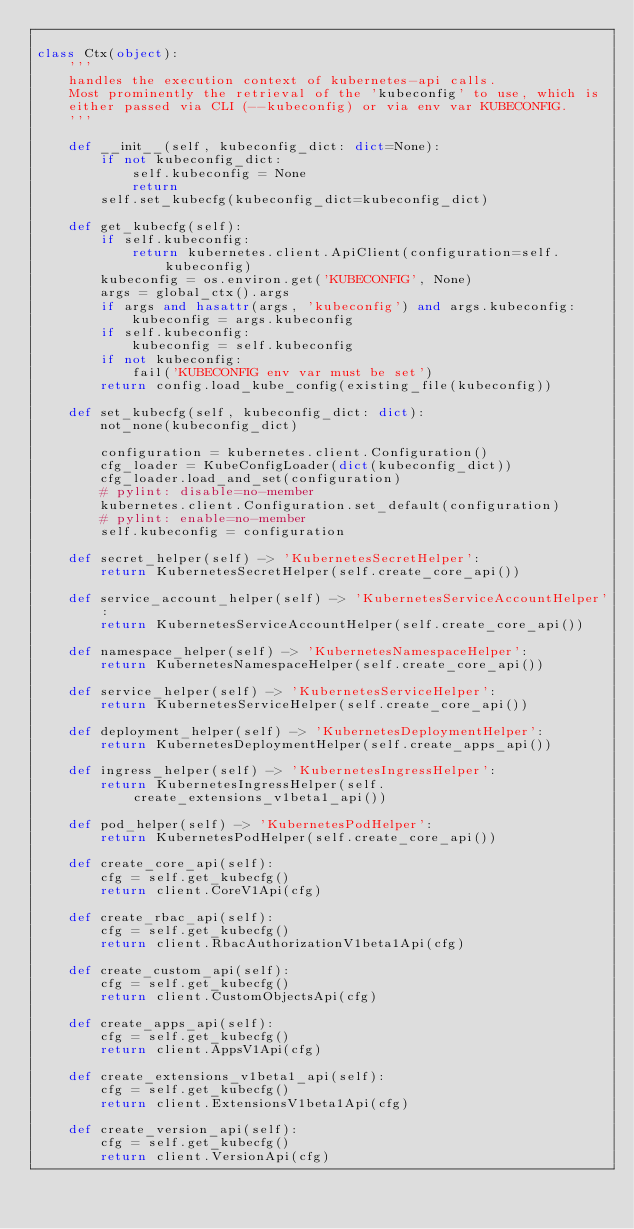Convert code to text. <code><loc_0><loc_0><loc_500><loc_500><_Python_>
class Ctx(object):
    '''
    handles the execution context of kubernetes-api calls.
    Most prominently the retrieval of the 'kubeconfig' to use, which is
    either passed via CLI (--kubeconfig) or via env var KUBECONFIG.
    '''

    def __init__(self, kubeconfig_dict: dict=None):
        if not kubeconfig_dict:
            self.kubeconfig = None
            return
        self.set_kubecfg(kubeconfig_dict=kubeconfig_dict)

    def get_kubecfg(self):
        if self.kubeconfig:
            return kubernetes.client.ApiClient(configuration=self.kubeconfig)
        kubeconfig = os.environ.get('KUBECONFIG', None)
        args = global_ctx().args
        if args and hasattr(args, 'kubeconfig') and args.kubeconfig:
            kubeconfig = args.kubeconfig
        if self.kubeconfig:
            kubeconfig = self.kubeconfig
        if not kubeconfig:
            fail('KUBECONFIG env var must be set')
        return config.load_kube_config(existing_file(kubeconfig))

    def set_kubecfg(self, kubeconfig_dict: dict):
        not_none(kubeconfig_dict)

        configuration = kubernetes.client.Configuration()
        cfg_loader = KubeConfigLoader(dict(kubeconfig_dict))
        cfg_loader.load_and_set(configuration)
        # pylint: disable=no-member
        kubernetes.client.Configuration.set_default(configuration)
        # pylint: enable=no-member
        self.kubeconfig = configuration

    def secret_helper(self) -> 'KubernetesSecretHelper':
        return KubernetesSecretHelper(self.create_core_api())

    def service_account_helper(self) -> 'KubernetesServiceAccountHelper':
        return KubernetesServiceAccountHelper(self.create_core_api())

    def namespace_helper(self) -> 'KubernetesNamespaceHelper':
        return KubernetesNamespaceHelper(self.create_core_api())

    def service_helper(self) -> 'KubernetesServiceHelper':
        return KubernetesServiceHelper(self.create_core_api())

    def deployment_helper(self) -> 'KubernetesDeploymentHelper':
        return KubernetesDeploymentHelper(self.create_apps_api())

    def ingress_helper(self) -> 'KubernetesIngressHelper':
        return KubernetesIngressHelper(self.create_extensions_v1beta1_api())

    def pod_helper(self) -> 'KubernetesPodHelper':
        return KubernetesPodHelper(self.create_core_api())

    def create_core_api(self):
        cfg = self.get_kubecfg()
        return client.CoreV1Api(cfg)

    def create_rbac_api(self):
        cfg = self.get_kubecfg()
        return client.RbacAuthorizationV1beta1Api(cfg)

    def create_custom_api(self):
        cfg = self.get_kubecfg()
        return client.CustomObjectsApi(cfg)

    def create_apps_api(self):
        cfg = self.get_kubecfg()
        return client.AppsV1Api(cfg)

    def create_extensions_v1beta1_api(self):
        cfg = self.get_kubecfg()
        return client.ExtensionsV1beta1Api(cfg)

    def create_version_api(self):
        cfg = self.get_kubecfg()
        return client.VersionApi(cfg)
</code> 